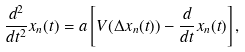Convert formula to latex. <formula><loc_0><loc_0><loc_500><loc_500>\frac { d ^ { 2 } } { d t ^ { 2 } } x _ { n } ( t ) = a \left [ V ( \Delta x _ { n } ( t ) ) - \frac { d } { d t } x _ { n } ( t ) \right ] ,</formula> 